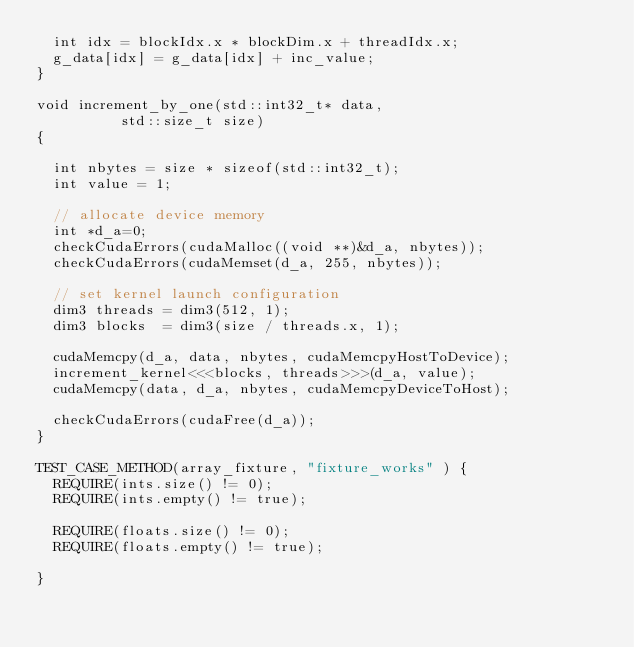Convert code to text. <code><loc_0><loc_0><loc_500><loc_500><_Cuda_>  int idx = blockIdx.x * blockDim.x + threadIdx.x;
  g_data[idx] = g_data[idx] + inc_value;
}

void increment_by_one(std::int32_t* data,
		      std::size_t size)
{

  int nbytes = size * sizeof(std::int32_t);
  int value = 1;

  // allocate device memory
  int *d_a=0;
  checkCudaErrors(cudaMalloc((void **)&d_a, nbytes));
  checkCudaErrors(cudaMemset(d_a, 255, nbytes));

  // set kernel launch configuration
  dim3 threads = dim3(512, 1);
  dim3 blocks  = dim3(size / threads.x, 1);

  cudaMemcpy(d_a, data, nbytes, cudaMemcpyHostToDevice);
  increment_kernel<<<blocks, threads>>>(d_a, value);
  cudaMemcpy(data, d_a, nbytes, cudaMemcpyDeviceToHost);

  checkCudaErrors(cudaFree(d_a));
}

TEST_CASE_METHOD(array_fixture, "fixture_works" ) {
  REQUIRE(ints.size() != 0);
  REQUIRE(ints.empty() != true);

  REQUIRE(floats.size() != 0);
  REQUIRE(floats.empty() != true);
 
}
</code> 